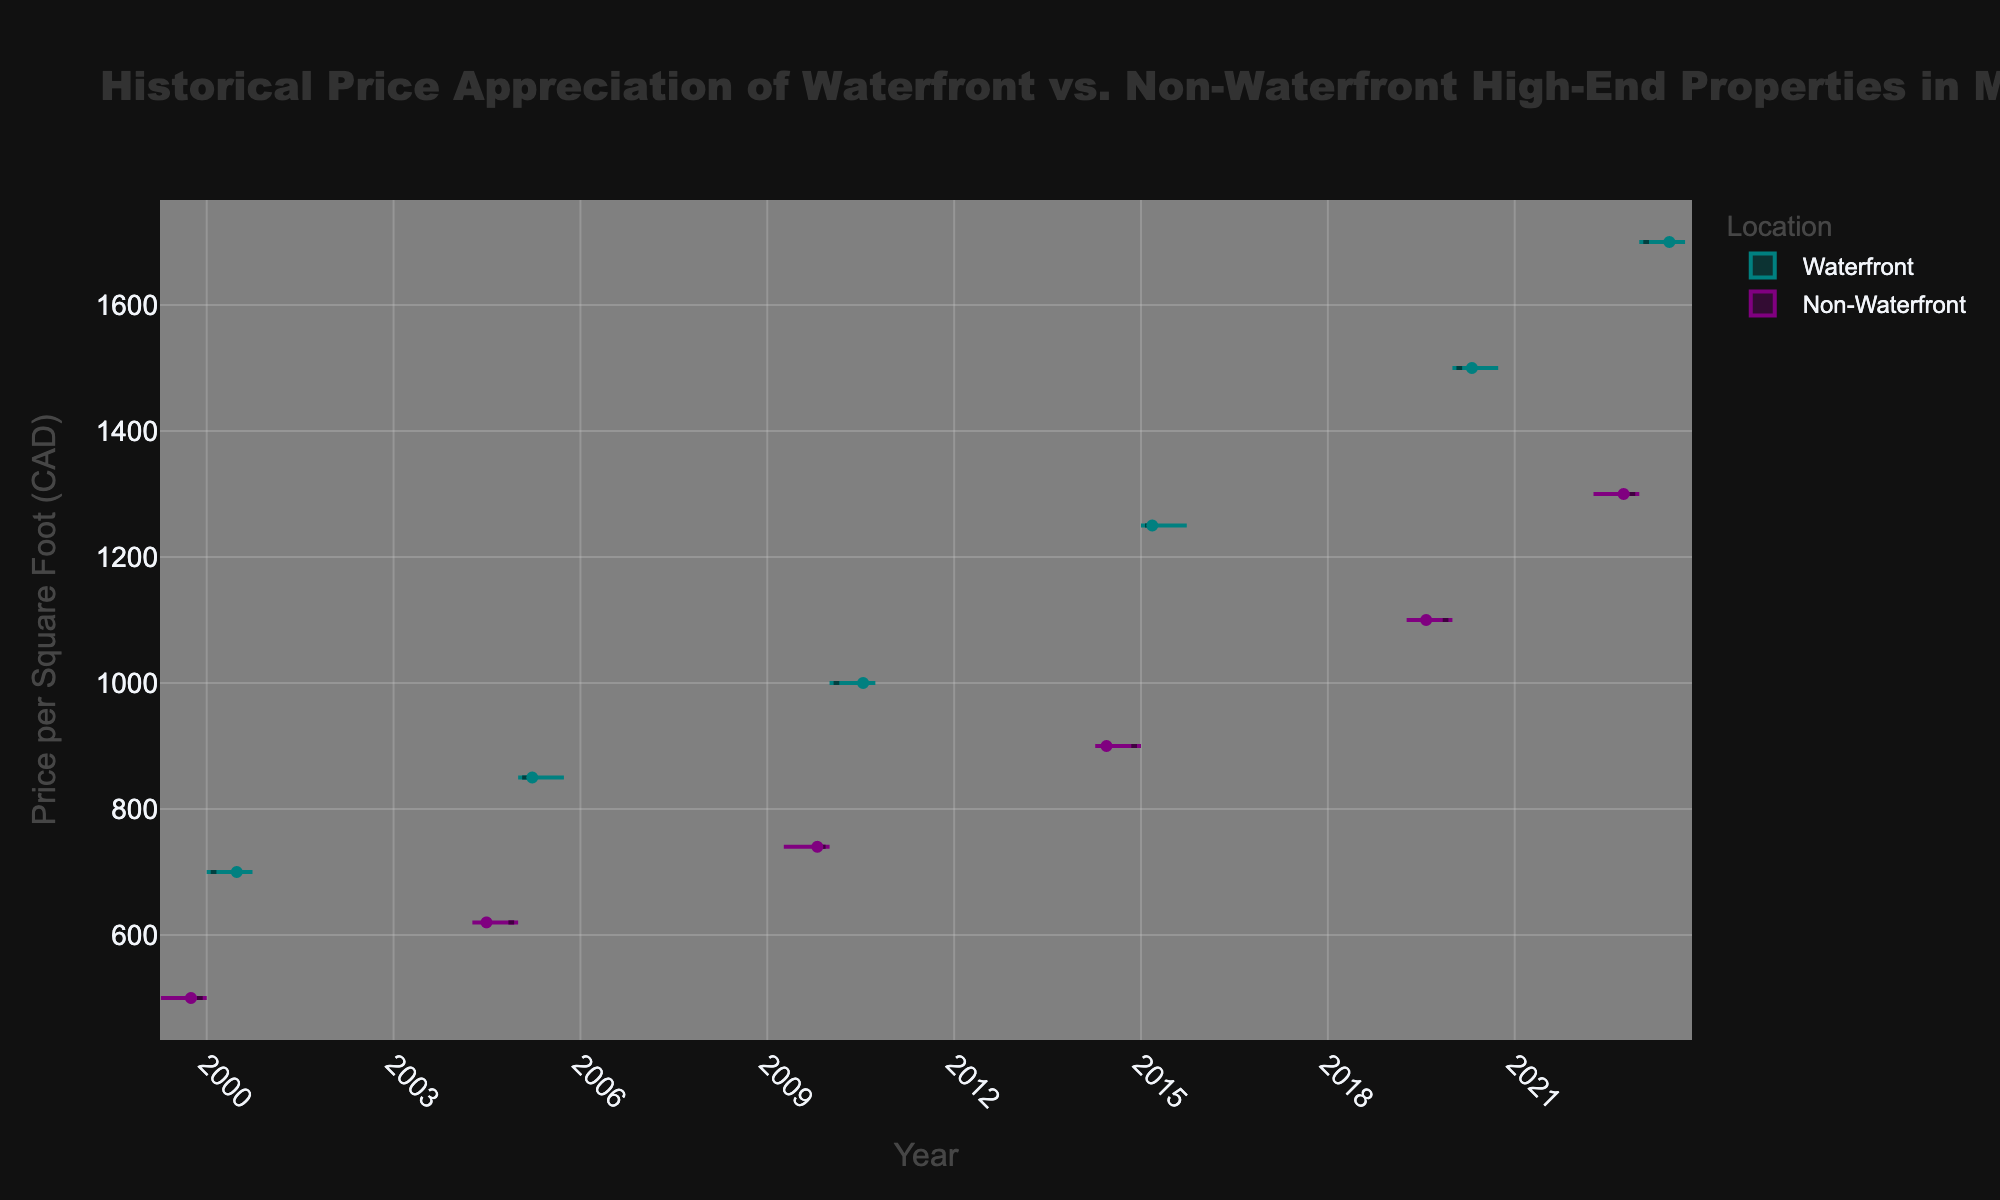What is the title of the figure? The title is generally located at the top of the figure in a larger font size, and it describes the main topic of the data visualization.
Answer: Historical Price Appreciation of Waterfront vs. Non-Waterfront High-End Properties in Montreal What does the x-axis represent? The x-axis is labeled and shows the timeline or years under consideration for the data points.
Answer: Year How do the price ranges for waterfront properties and non-waterfront properties compare in 2023? By looking at the spread of the violin plots for the year 2023, we can observe the range for their respective prices per square foot. Waterfront properties range from 1500 to 1700 CAD, while non-waterfront properties range from 1100 to 1300 CAD.
Answer: Waterfront: 1500-1700 CAD, Non-Waterfront: 1100-1300 CAD What is the average price per square foot for waterfront properties in 2020? The average is represented by the mean line within the violin plot. For 2020, locate the mean line in the waterfront plot.
Answer: 1500 CAD Which location type shows a wider range of prices in 2015? Compare the widths of the violin plots for waterfront and non-waterfront properties in 2015 to determine which has a broader spread. Waterfront properties show a wider range between 1250 and 1250 CAD, whereas non-waterfront properties show a range between 900 and 900 CAD.
Answer: Neither, both have a single data point In which year did both waterfront and non-waterfront properties have their highest price per square foot? Look for the year where both violin plots reach their highest points along the y-axis. That would be for the year 2023.
Answer: 2023 How does the price trend for waterfront properties change from 2000 to 2023? by observing the mean lines for waterfront properties over the years, one can determine the increasing trend from 700 to 1700 CAD from 2000 to 2023.
Answer: Increasing trend Which type of properties shows a higher appreciation in price per square foot from 2000 to 2023? Calculate the difference in price per square foot between 2000 and 2023 for both property types and compare them. Waterfront properties increased by 1700 - 700 = 1000 CAD, and non-waterfront properties increased by 1300 - 500 = 800 CAD.
Answer: Waterfront properties Comparing waterfront and non-waterfront properties, which one had consistently higher prices throughout the years? By observing the position of the mean lines in the violin plots for each year, waterfront properties consistently show higher prices than non-waterfront properties.
Answer: Waterfront properties What is the color used to represent non-waterfront properties? The color of the data points and plot area for non-waterfront properties can be identified visually within the figure.
Answer: Purple 